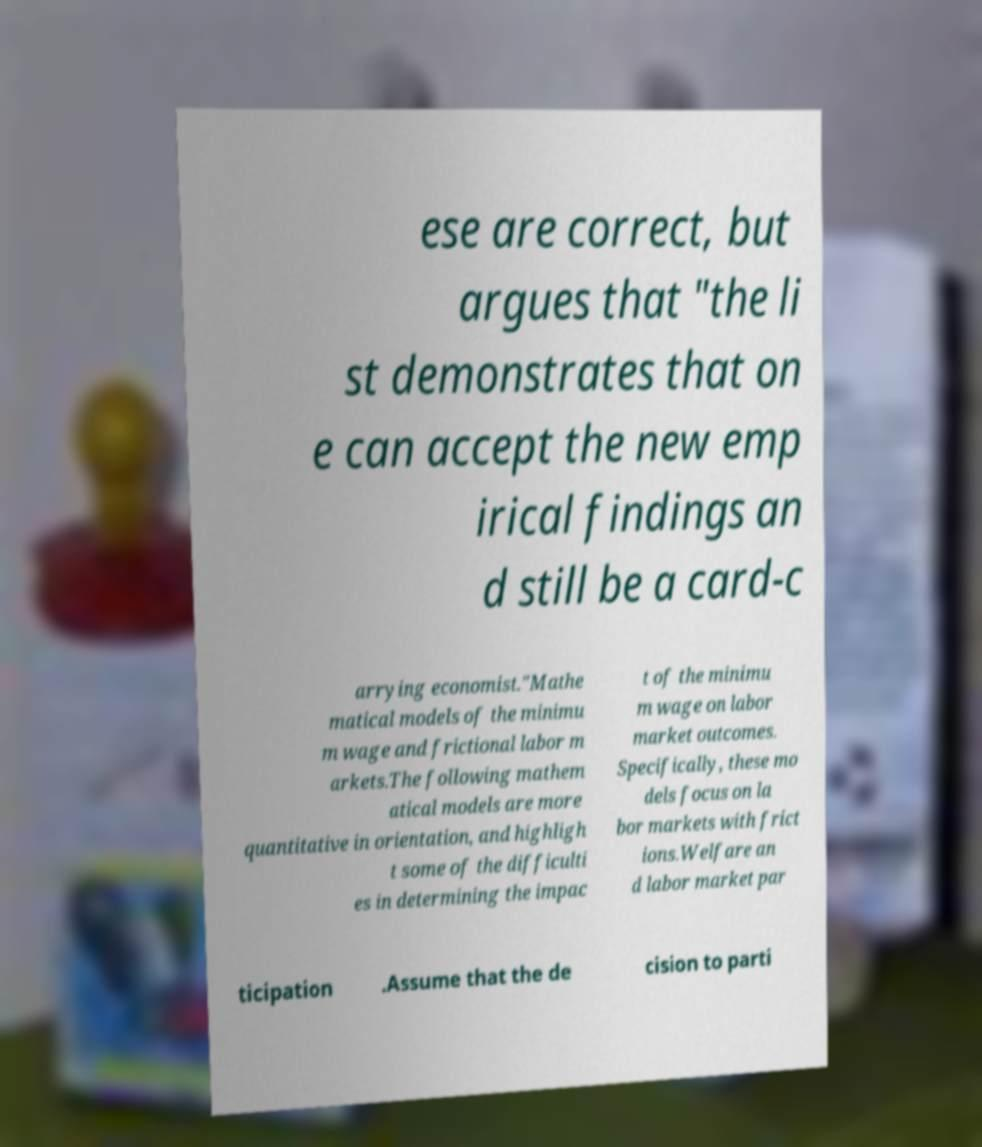Could you extract and type out the text from this image? ese are correct, but argues that "the li st demonstrates that on e can accept the new emp irical findings an d still be a card-c arrying economist."Mathe matical models of the minimu m wage and frictional labor m arkets.The following mathem atical models are more quantitative in orientation, and highligh t some of the difficulti es in determining the impac t of the minimu m wage on labor market outcomes. Specifically, these mo dels focus on la bor markets with frict ions.Welfare an d labor market par ticipation .Assume that the de cision to parti 